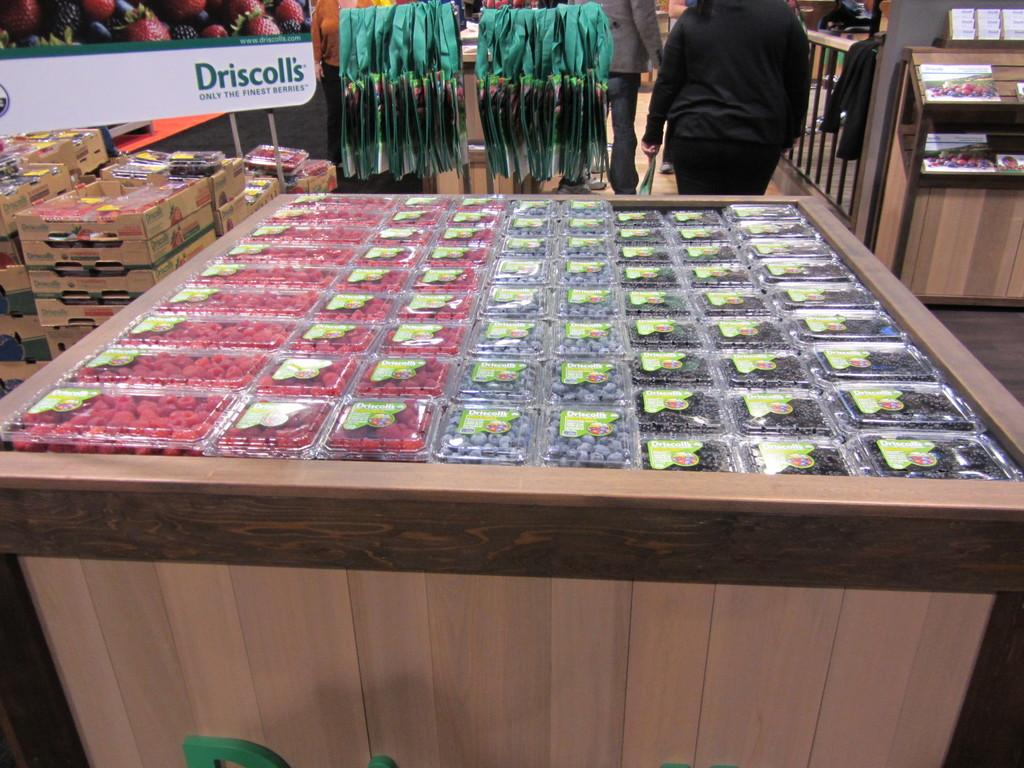<image>
Summarize the visual content of the image. A sign advertises Driscoll's as being "only the finest berries." 